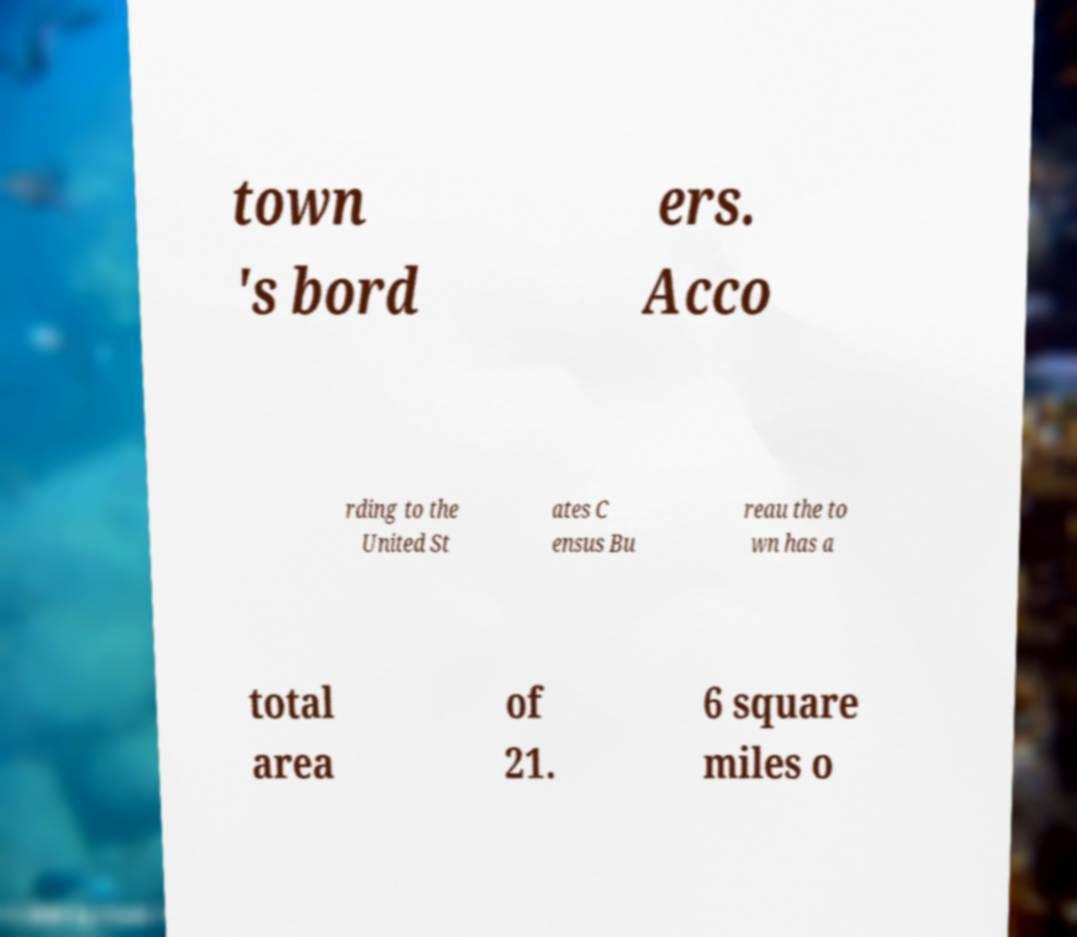Could you assist in decoding the text presented in this image and type it out clearly? town 's bord ers. Acco rding to the United St ates C ensus Bu reau the to wn has a total area of 21. 6 square miles o 